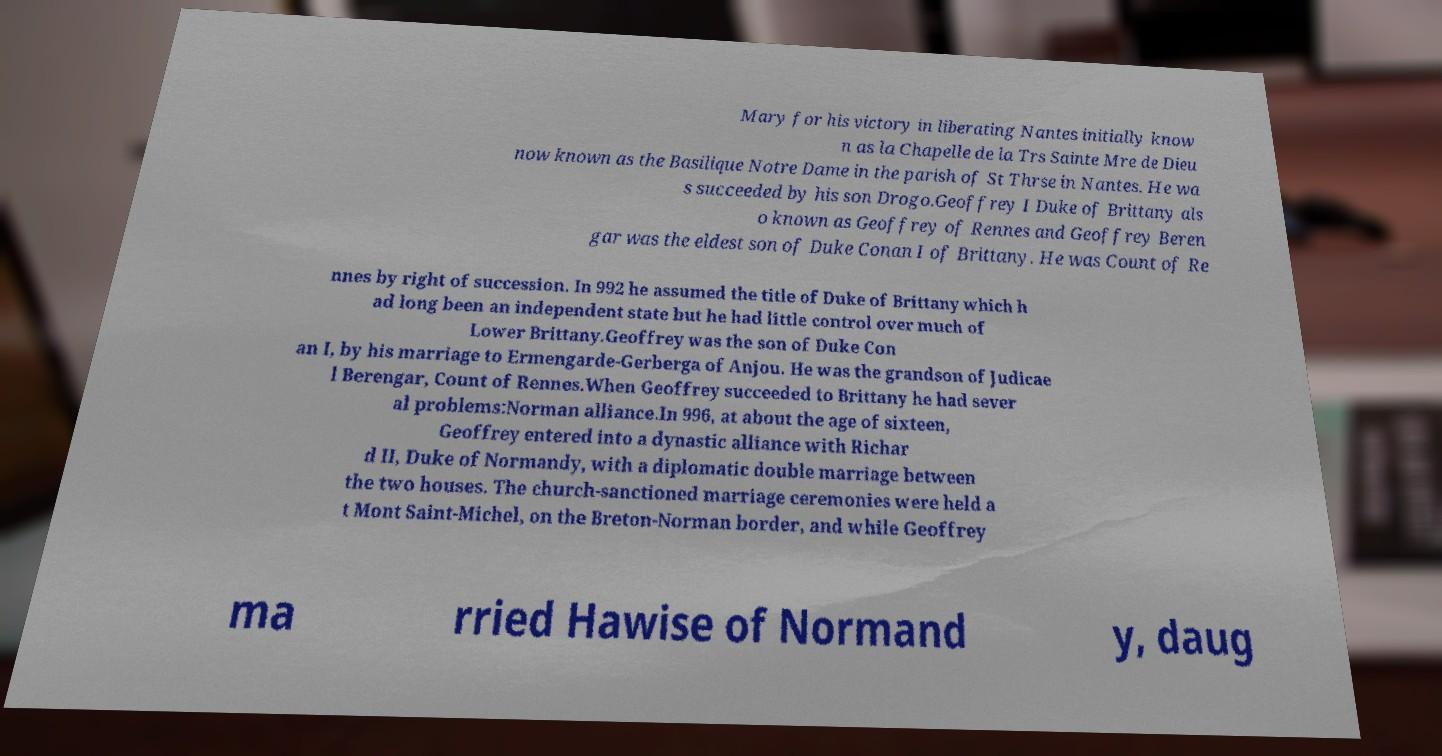Please identify and transcribe the text found in this image. Mary for his victory in liberating Nantes initially know n as la Chapelle de la Trs Sainte Mre de Dieu now known as the Basilique Notre Dame in the parish of St Thrse in Nantes. He wa s succeeded by his son Drogo.Geoffrey I Duke of Brittany als o known as Geoffrey of Rennes and Geoffrey Beren gar was the eldest son of Duke Conan I of Brittany. He was Count of Re nnes by right of succession. In 992 he assumed the title of Duke of Brittany which h ad long been an independent state but he had little control over much of Lower Brittany.Geoffrey was the son of Duke Con an I, by his marriage to Ermengarde-Gerberga of Anjou. He was the grandson of Judicae l Berengar, Count of Rennes.When Geoffrey succeeded to Brittany he had sever al problems:Norman alliance.In 996, at about the age of sixteen, Geoffrey entered into a dynastic alliance with Richar d II, Duke of Normandy, with a diplomatic double marriage between the two houses. The church-sanctioned marriage ceremonies were held a t Mont Saint-Michel, on the Breton-Norman border, and while Geoffrey ma rried Hawise of Normand y, daug 